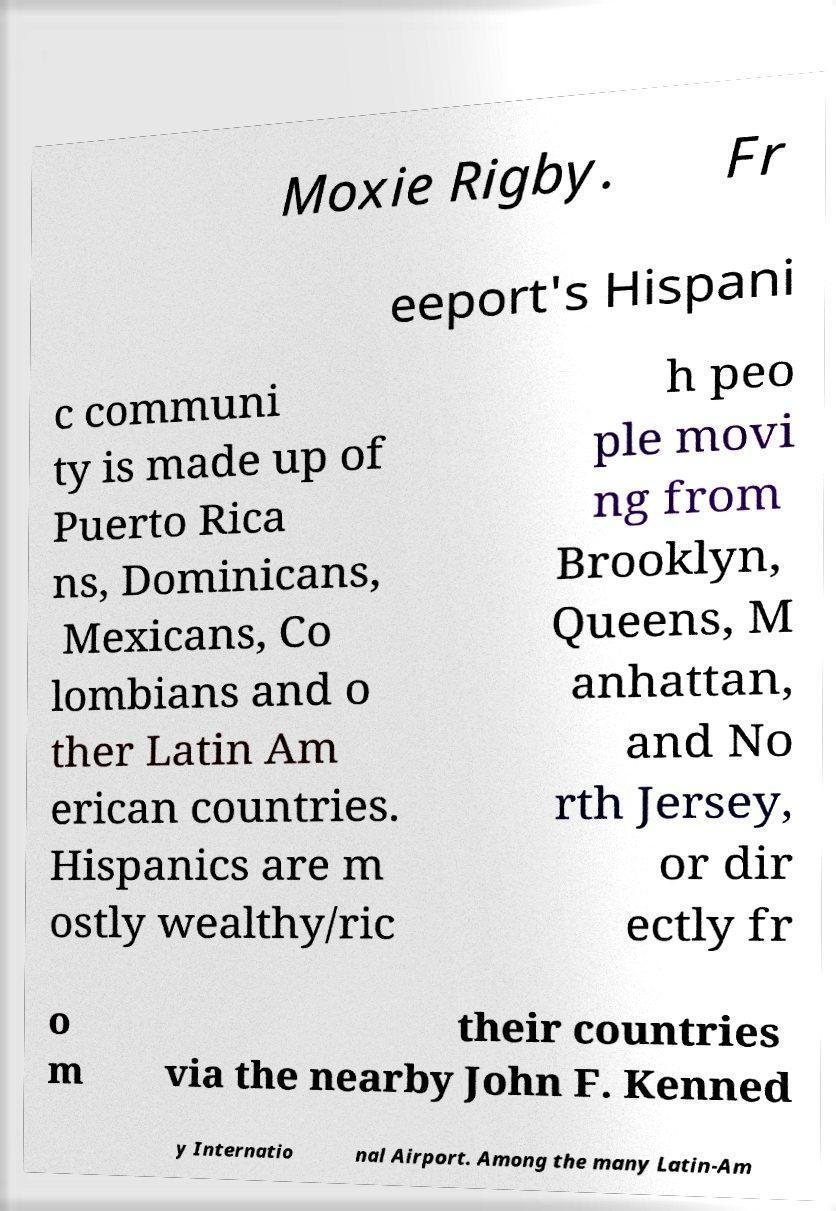What messages or text are displayed in this image? I need them in a readable, typed format. Moxie Rigby. Fr eeport's Hispani c communi ty is made up of Puerto Rica ns, Dominicans, Mexicans, Co lombians and o ther Latin Am erican countries. Hispanics are m ostly wealthy/ric h peo ple movi ng from Brooklyn, Queens, M anhattan, and No rth Jersey, or dir ectly fr o m their countries via the nearby John F. Kenned y Internatio nal Airport. Among the many Latin-Am 